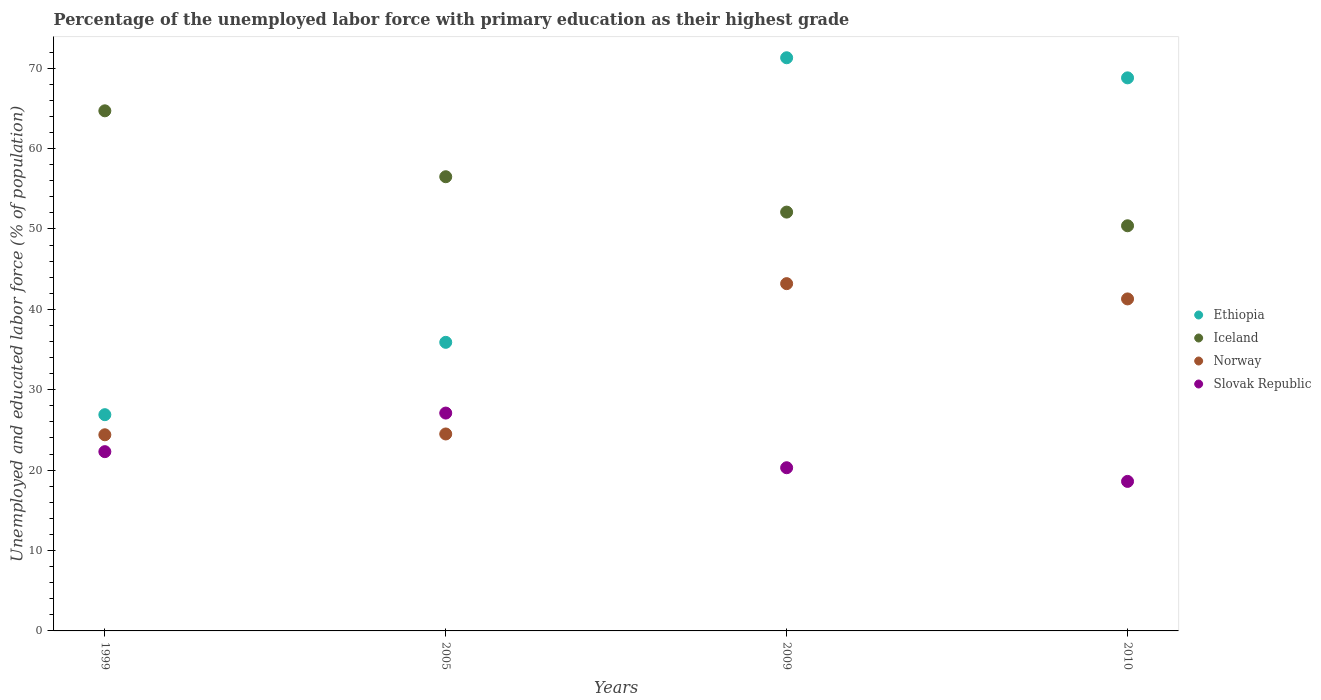What is the percentage of the unemployed labor force with primary education in Iceland in 2005?
Keep it short and to the point. 56.5. Across all years, what is the maximum percentage of the unemployed labor force with primary education in Slovak Republic?
Offer a terse response. 27.1. Across all years, what is the minimum percentage of the unemployed labor force with primary education in Slovak Republic?
Give a very brief answer. 18.6. In which year was the percentage of the unemployed labor force with primary education in Ethiopia minimum?
Ensure brevity in your answer.  1999. What is the total percentage of the unemployed labor force with primary education in Iceland in the graph?
Provide a succinct answer. 223.7. What is the difference between the percentage of the unemployed labor force with primary education in Iceland in 2005 and that in 2009?
Give a very brief answer. 4.4. What is the difference between the percentage of the unemployed labor force with primary education in Iceland in 1999 and the percentage of the unemployed labor force with primary education in Slovak Republic in 2010?
Your answer should be compact. 46.1. What is the average percentage of the unemployed labor force with primary education in Iceland per year?
Your answer should be compact. 55.92. In the year 2005, what is the difference between the percentage of the unemployed labor force with primary education in Norway and percentage of the unemployed labor force with primary education in Ethiopia?
Your answer should be compact. -11.4. What is the ratio of the percentage of the unemployed labor force with primary education in Ethiopia in 1999 to that in 2009?
Provide a succinct answer. 0.38. Is the difference between the percentage of the unemployed labor force with primary education in Norway in 1999 and 2010 greater than the difference between the percentage of the unemployed labor force with primary education in Ethiopia in 1999 and 2010?
Your answer should be very brief. Yes. What is the difference between the highest and the second highest percentage of the unemployed labor force with primary education in Norway?
Ensure brevity in your answer.  1.9. What is the difference between the highest and the lowest percentage of the unemployed labor force with primary education in Norway?
Your answer should be compact. 18.8. Is the sum of the percentage of the unemployed labor force with primary education in Norway in 2009 and 2010 greater than the maximum percentage of the unemployed labor force with primary education in Iceland across all years?
Your answer should be very brief. Yes. Is it the case that in every year, the sum of the percentage of the unemployed labor force with primary education in Iceland and percentage of the unemployed labor force with primary education in Norway  is greater than the sum of percentage of the unemployed labor force with primary education in Ethiopia and percentage of the unemployed labor force with primary education in Slovak Republic?
Make the answer very short. No. Is it the case that in every year, the sum of the percentage of the unemployed labor force with primary education in Slovak Republic and percentage of the unemployed labor force with primary education in Norway  is greater than the percentage of the unemployed labor force with primary education in Iceland?
Your answer should be very brief. No. Does the percentage of the unemployed labor force with primary education in Ethiopia monotonically increase over the years?
Make the answer very short. No. Is the percentage of the unemployed labor force with primary education in Slovak Republic strictly greater than the percentage of the unemployed labor force with primary education in Ethiopia over the years?
Make the answer very short. No. Is the percentage of the unemployed labor force with primary education in Norway strictly less than the percentage of the unemployed labor force with primary education in Iceland over the years?
Offer a terse response. Yes. What is the difference between two consecutive major ticks on the Y-axis?
Keep it short and to the point. 10. Are the values on the major ticks of Y-axis written in scientific E-notation?
Provide a succinct answer. No. How are the legend labels stacked?
Offer a terse response. Vertical. What is the title of the graph?
Keep it short and to the point. Percentage of the unemployed labor force with primary education as their highest grade. Does "Tunisia" appear as one of the legend labels in the graph?
Your response must be concise. No. What is the label or title of the X-axis?
Your answer should be very brief. Years. What is the label or title of the Y-axis?
Ensure brevity in your answer.  Unemployed and educated labor force (% of population). What is the Unemployed and educated labor force (% of population) in Ethiopia in 1999?
Your response must be concise. 26.9. What is the Unemployed and educated labor force (% of population) in Iceland in 1999?
Offer a terse response. 64.7. What is the Unemployed and educated labor force (% of population) of Norway in 1999?
Make the answer very short. 24.4. What is the Unemployed and educated labor force (% of population) in Slovak Republic in 1999?
Provide a succinct answer. 22.3. What is the Unemployed and educated labor force (% of population) in Ethiopia in 2005?
Your answer should be very brief. 35.9. What is the Unemployed and educated labor force (% of population) in Iceland in 2005?
Your response must be concise. 56.5. What is the Unemployed and educated labor force (% of population) of Slovak Republic in 2005?
Your answer should be compact. 27.1. What is the Unemployed and educated labor force (% of population) in Ethiopia in 2009?
Provide a short and direct response. 71.3. What is the Unemployed and educated labor force (% of population) of Iceland in 2009?
Your answer should be compact. 52.1. What is the Unemployed and educated labor force (% of population) in Norway in 2009?
Make the answer very short. 43.2. What is the Unemployed and educated labor force (% of population) in Slovak Republic in 2009?
Make the answer very short. 20.3. What is the Unemployed and educated labor force (% of population) of Ethiopia in 2010?
Ensure brevity in your answer.  68.8. What is the Unemployed and educated labor force (% of population) in Iceland in 2010?
Offer a very short reply. 50.4. What is the Unemployed and educated labor force (% of population) in Norway in 2010?
Your answer should be compact. 41.3. What is the Unemployed and educated labor force (% of population) of Slovak Republic in 2010?
Your answer should be very brief. 18.6. Across all years, what is the maximum Unemployed and educated labor force (% of population) in Ethiopia?
Your answer should be very brief. 71.3. Across all years, what is the maximum Unemployed and educated labor force (% of population) of Iceland?
Provide a short and direct response. 64.7. Across all years, what is the maximum Unemployed and educated labor force (% of population) of Norway?
Your answer should be very brief. 43.2. Across all years, what is the maximum Unemployed and educated labor force (% of population) of Slovak Republic?
Provide a succinct answer. 27.1. Across all years, what is the minimum Unemployed and educated labor force (% of population) in Ethiopia?
Offer a terse response. 26.9. Across all years, what is the minimum Unemployed and educated labor force (% of population) in Iceland?
Provide a succinct answer. 50.4. Across all years, what is the minimum Unemployed and educated labor force (% of population) in Norway?
Provide a succinct answer. 24.4. Across all years, what is the minimum Unemployed and educated labor force (% of population) of Slovak Republic?
Offer a terse response. 18.6. What is the total Unemployed and educated labor force (% of population) in Ethiopia in the graph?
Offer a very short reply. 202.9. What is the total Unemployed and educated labor force (% of population) of Iceland in the graph?
Offer a very short reply. 223.7. What is the total Unemployed and educated labor force (% of population) of Norway in the graph?
Keep it short and to the point. 133.4. What is the total Unemployed and educated labor force (% of population) in Slovak Republic in the graph?
Provide a short and direct response. 88.3. What is the difference between the Unemployed and educated labor force (% of population) in Ethiopia in 1999 and that in 2005?
Give a very brief answer. -9. What is the difference between the Unemployed and educated labor force (% of population) in Ethiopia in 1999 and that in 2009?
Keep it short and to the point. -44.4. What is the difference between the Unemployed and educated labor force (% of population) in Norway in 1999 and that in 2009?
Make the answer very short. -18.8. What is the difference between the Unemployed and educated labor force (% of population) in Slovak Republic in 1999 and that in 2009?
Your answer should be very brief. 2. What is the difference between the Unemployed and educated labor force (% of population) of Ethiopia in 1999 and that in 2010?
Provide a succinct answer. -41.9. What is the difference between the Unemployed and educated labor force (% of population) in Norway in 1999 and that in 2010?
Your answer should be very brief. -16.9. What is the difference between the Unemployed and educated labor force (% of population) of Ethiopia in 2005 and that in 2009?
Provide a succinct answer. -35.4. What is the difference between the Unemployed and educated labor force (% of population) in Iceland in 2005 and that in 2009?
Your answer should be compact. 4.4. What is the difference between the Unemployed and educated labor force (% of population) of Norway in 2005 and that in 2009?
Your response must be concise. -18.7. What is the difference between the Unemployed and educated labor force (% of population) in Ethiopia in 2005 and that in 2010?
Make the answer very short. -32.9. What is the difference between the Unemployed and educated labor force (% of population) of Iceland in 2005 and that in 2010?
Your answer should be compact. 6.1. What is the difference between the Unemployed and educated labor force (% of population) of Norway in 2005 and that in 2010?
Your response must be concise. -16.8. What is the difference between the Unemployed and educated labor force (% of population) of Ethiopia in 2009 and that in 2010?
Your answer should be compact. 2.5. What is the difference between the Unemployed and educated labor force (% of population) in Iceland in 2009 and that in 2010?
Your answer should be very brief. 1.7. What is the difference between the Unemployed and educated labor force (% of population) in Norway in 2009 and that in 2010?
Your response must be concise. 1.9. What is the difference between the Unemployed and educated labor force (% of population) in Ethiopia in 1999 and the Unemployed and educated labor force (% of population) in Iceland in 2005?
Ensure brevity in your answer.  -29.6. What is the difference between the Unemployed and educated labor force (% of population) in Ethiopia in 1999 and the Unemployed and educated labor force (% of population) in Norway in 2005?
Offer a terse response. 2.4. What is the difference between the Unemployed and educated labor force (% of population) of Ethiopia in 1999 and the Unemployed and educated labor force (% of population) of Slovak Republic in 2005?
Make the answer very short. -0.2. What is the difference between the Unemployed and educated labor force (% of population) of Iceland in 1999 and the Unemployed and educated labor force (% of population) of Norway in 2005?
Your answer should be very brief. 40.2. What is the difference between the Unemployed and educated labor force (% of population) of Iceland in 1999 and the Unemployed and educated labor force (% of population) of Slovak Republic in 2005?
Make the answer very short. 37.6. What is the difference between the Unemployed and educated labor force (% of population) in Ethiopia in 1999 and the Unemployed and educated labor force (% of population) in Iceland in 2009?
Offer a terse response. -25.2. What is the difference between the Unemployed and educated labor force (% of population) in Ethiopia in 1999 and the Unemployed and educated labor force (% of population) in Norway in 2009?
Your answer should be very brief. -16.3. What is the difference between the Unemployed and educated labor force (% of population) in Iceland in 1999 and the Unemployed and educated labor force (% of population) in Slovak Republic in 2009?
Provide a short and direct response. 44.4. What is the difference between the Unemployed and educated labor force (% of population) of Ethiopia in 1999 and the Unemployed and educated labor force (% of population) of Iceland in 2010?
Offer a very short reply. -23.5. What is the difference between the Unemployed and educated labor force (% of population) of Ethiopia in 1999 and the Unemployed and educated labor force (% of population) of Norway in 2010?
Keep it short and to the point. -14.4. What is the difference between the Unemployed and educated labor force (% of population) of Iceland in 1999 and the Unemployed and educated labor force (% of population) of Norway in 2010?
Provide a succinct answer. 23.4. What is the difference between the Unemployed and educated labor force (% of population) of Iceland in 1999 and the Unemployed and educated labor force (% of population) of Slovak Republic in 2010?
Your response must be concise. 46.1. What is the difference between the Unemployed and educated labor force (% of population) of Ethiopia in 2005 and the Unemployed and educated labor force (% of population) of Iceland in 2009?
Provide a short and direct response. -16.2. What is the difference between the Unemployed and educated labor force (% of population) of Iceland in 2005 and the Unemployed and educated labor force (% of population) of Norway in 2009?
Offer a very short reply. 13.3. What is the difference between the Unemployed and educated labor force (% of population) in Iceland in 2005 and the Unemployed and educated labor force (% of population) in Slovak Republic in 2009?
Your answer should be very brief. 36.2. What is the difference between the Unemployed and educated labor force (% of population) in Norway in 2005 and the Unemployed and educated labor force (% of population) in Slovak Republic in 2009?
Provide a succinct answer. 4.2. What is the difference between the Unemployed and educated labor force (% of population) of Ethiopia in 2005 and the Unemployed and educated labor force (% of population) of Iceland in 2010?
Provide a succinct answer. -14.5. What is the difference between the Unemployed and educated labor force (% of population) in Ethiopia in 2005 and the Unemployed and educated labor force (% of population) in Slovak Republic in 2010?
Offer a terse response. 17.3. What is the difference between the Unemployed and educated labor force (% of population) of Iceland in 2005 and the Unemployed and educated labor force (% of population) of Norway in 2010?
Provide a succinct answer. 15.2. What is the difference between the Unemployed and educated labor force (% of population) of Iceland in 2005 and the Unemployed and educated labor force (% of population) of Slovak Republic in 2010?
Give a very brief answer. 37.9. What is the difference between the Unemployed and educated labor force (% of population) in Ethiopia in 2009 and the Unemployed and educated labor force (% of population) in Iceland in 2010?
Your answer should be compact. 20.9. What is the difference between the Unemployed and educated labor force (% of population) of Ethiopia in 2009 and the Unemployed and educated labor force (% of population) of Norway in 2010?
Provide a succinct answer. 30. What is the difference between the Unemployed and educated labor force (% of population) in Ethiopia in 2009 and the Unemployed and educated labor force (% of population) in Slovak Republic in 2010?
Offer a very short reply. 52.7. What is the difference between the Unemployed and educated labor force (% of population) of Iceland in 2009 and the Unemployed and educated labor force (% of population) of Slovak Republic in 2010?
Your answer should be compact. 33.5. What is the difference between the Unemployed and educated labor force (% of population) of Norway in 2009 and the Unemployed and educated labor force (% of population) of Slovak Republic in 2010?
Your answer should be very brief. 24.6. What is the average Unemployed and educated labor force (% of population) in Ethiopia per year?
Make the answer very short. 50.73. What is the average Unemployed and educated labor force (% of population) of Iceland per year?
Offer a very short reply. 55.92. What is the average Unemployed and educated labor force (% of population) in Norway per year?
Your answer should be compact. 33.35. What is the average Unemployed and educated labor force (% of population) in Slovak Republic per year?
Give a very brief answer. 22.07. In the year 1999, what is the difference between the Unemployed and educated labor force (% of population) of Ethiopia and Unemployed and educated labor force (% of population) of Iceland?
Offer a very short reply. -37.8. In the year 1999, what is the difference between the Unemployed and educated labor force (% of population) in Ethiopia and Unemployed and educated labor force (% of population) in Slovak Republic?
Provide a short and direct response. 4.6. In the year 1999, what is the difference between the Unemployed and educated labor force (% of population) of Iceland and Unemployed and educated labor force (% of population) of Norway?
Ensure brevity in your answer.  40.3. In the year 1999, what is the difference between the Unemployed and educated labor force (% of population) of Iceland and Unemployed and educated labor force (% of population) of Slovak Republic?
Your response must be concise. 42.4. In the year 1999, what is the difference between the Unemployed and educated labor force (% of population) in Norway and Unemployed and educated labor force (% of population) in Slovak Republic?
Provide a succinct answer. 2.1. In the year 2005, what is the difference between the Unemployed and educated labor force (% of population) of Ethiopia and Unemployed and educated labor force (% of population) of Iceland?
Ensure brevity in your answer.  -20.6. In the year 2005, what is the difference between the Unemployed and educated labor force (% of population) of Ethiopia and Unemployed and educated labor force (% of population) of Slovak Republic?
Make the answer very short. 8.8. In the year 2005, what is the difference between the Unemployed and educated labor force (% of population) in Iceland and Unemployed and educated labor force (% of population) in Slovak Republic?
Ensure brevity in your answer.  29.4. In the year 2009, what is the difference between the Unemployed and educated labor force (% of population) of Ethiopia and Unemployed and educated labor force (% of population) of Iceland?
Your response must be concise. 19.2. In the year 2009, what is the difference between the Unemployed and educated labor force (% of population) in Ethiopia and Unemployed and educated labor force (% of population) in Norway?
Your answer should be very brief. 28.1. In the year 2009, what is the difference between the Unemployed and educated labor force (% of population) in Ethiopia and Unemployed and educated labor force (% of population) in Slovak Republic?
Your response must be concise. 51. In the year 2009, what is the difference between the Unemployed and educated labor force (% of population) of Iceland and Unemployed and educated labor force (% of population) of Norway?
Your answer should be very brief. 8.9. In the year 2009, what is the difference between the Unemployed and educated labor force (% of population) of Iceland and Unemployed and educated labor force (% of population) of Slovak Republic?
Provide a succinct answer. 31.8. In the year 2009, what is the difference between the Unemployed and educated labor force (% of population) of Norway and Unemployed and educated labor force (% of population) of Slovak Republic?
Provide a succinct answer. 22.9. In the year 2010, what is the difference between the Unemployed and educated labor force (% of population) of Ethiopia and Unemployed and educated labor force (% of population) of Iceland?
Ensure brevity in your answer.  18.4. In the year 2010, what is the difference between the Unemployed and educated labor force (% of population) of Ethiopia and Unemployed and educated labor force (% of population) of Slovak Republic?
Your response must be concise. 50.2. In the year 2010, what is the difference between the Unemployed and educated labor force (% of population) in Iceland and Unemployed and educated labor force (% of population) in Norway?
Your answer should be very brief. 9.1. In the year 2010, what is the difference between the Unemployed and educated labor force (% of population) of Iceland and Unemployed and educated labor force (% of population) of Slovak Republic?
Provide a succinct answer. 31.8. In the year 2010, what is the difference between the Unemployed and educated labor force (% of population) of Norway and Unemployed and educated labor force (% of population) of Slovak Republic?
Provide a succinct answer. 22.7. What is the ratio of the Unemployed and educated labor force (% of population) of Ethiopia in 1999 to that in 2005?
Provide a succinct answer. 0.75. What is the ratio of the Unemployed and educated labor force (% of population) in Iceland in 1999 to that in 2005?
Offer a terse response. 1.15. What is the ratio of the Unemployed and educated labor force (% of population) of Norway in 1999 to that in 2005?
Offer a very short reply. 1. What is the ratio of the Unemployed and educated labor force (% of population) of Slovak Republic in 1999 to that in 2005?
Offer a terse response. 0.82. What is the ratio of the Unemployed and educated labor force (% of population) in Ethiopia in 1999 to that in 2009?
Provide a short and direct response. 0.38. What is the ratio of the Unemployed and educated labor force (% of population) in Iceland in 1999 to that in 2009?
Make the answer very short. 1.24. What is the ratio of the Unemployed and educated labor force (% of population) in Norway in 1999 to that in 2009?
Make the answer very short. 0.56. What is the ratio of the Unemployed and educated labor force (% of population) in Slovak Republic in 1999 to that in 2009?
Give a very brief answer. 1.1. What is the ratio of the Unemployed and educated labor force (% of population) of Ethiopia in 1999 to that in 2010?
Offer a terse response. 0.39. What is the ratio of the Unemployed and educated labor force (% of population) in Iceland in 1999 to that in 2010?
Give a very brief answer. 1.28. What is the ratio of the Unemployed and educated labor force (% of population) in Norway in 1999 to that in 2010?
Keep it short and to the point. 0.59. What is the ratio of the Unemployed and educated labor force (% of population) in Slovak Republic in 1999 to that in 2010?
Offer a terse response. 1.2. What is the ratio of the Unemployed and educated labor force (% of population) of Ethiopia in 2005 to that in 2009?
Provide a succinct answer. 0.5. What is the ratio of the Unemployed and educated labor force (% of population) of Iceland in 2005 to that in 2009?
Provide a succinct answer. 1.08. What is the ratio of the Unemployed and educated labor force (% of population) of Norway in 2005 to that in 2009?
Your answer should be compact. 0.57. What is the ratio of the Unemployed and educated labor force (% of population) in Slovak Republic in 2005 to that in 2009?
Your answer should be compact. 1.33. What is the ratio of the Unemployed and educated labor force (% of population) of Ethiopia in 2005 to that in 2010?
Ensure brevity in your answer.  0.52. What is the ratio of the Unemployed and educated labor force (% of population) in Iceland in 2005 to that in 2010?
Offer a terse response. 1.12. What is the ratio of the Unemployed and educated labor force (% of population) in Norway in 2005 to that in 2010?
Your response must be concise. 0.59. What is the ratio of the Unemployed and educated labor force (% of population) of Slovak Republic in 2005 to that in 2010?
Provide a succinct answer. 1.46. What is the ratio of the Unemployed and educated labor force (% of population) of Ethiopia in 2009 to that in 2010?
Your answer should be very brief. 1.04. What is the ratio of the Unemployed and educated labor force (% of population) in Iceland in 2009 to that in 2010?
Ensure brevity in your answer.  1.03. What is the ratio of the Unemployed and educated labor force (% of population) in Norway in 2009 to that in 2010?
Give a very brief answer. 1.05. What is the ratio of the Unemployed and educated labor force (% of population) of Slovak Republic in 2009 to that in 2010?
Your answer should be compact. 1.09. What is the difference between the highest and the second highest Unemployed and educated labor force (% of population) of Ethiopia?
Keep it short and to the point. 2.5. What is the difference between the highest and the lowest Unemployed and educated labor force (% of population) of Ethiopia?
Offer a very short reply. 44.4. What is the difference between the highest and the lowest Unemployed and educated labor force (% of population) of Iceland?
Your response must be concise. 14.3. What is the difference between the highest and the lowest Unemployed and educated labor force (% of population) in Norway?
Your answer should be very brief. 18.8. 